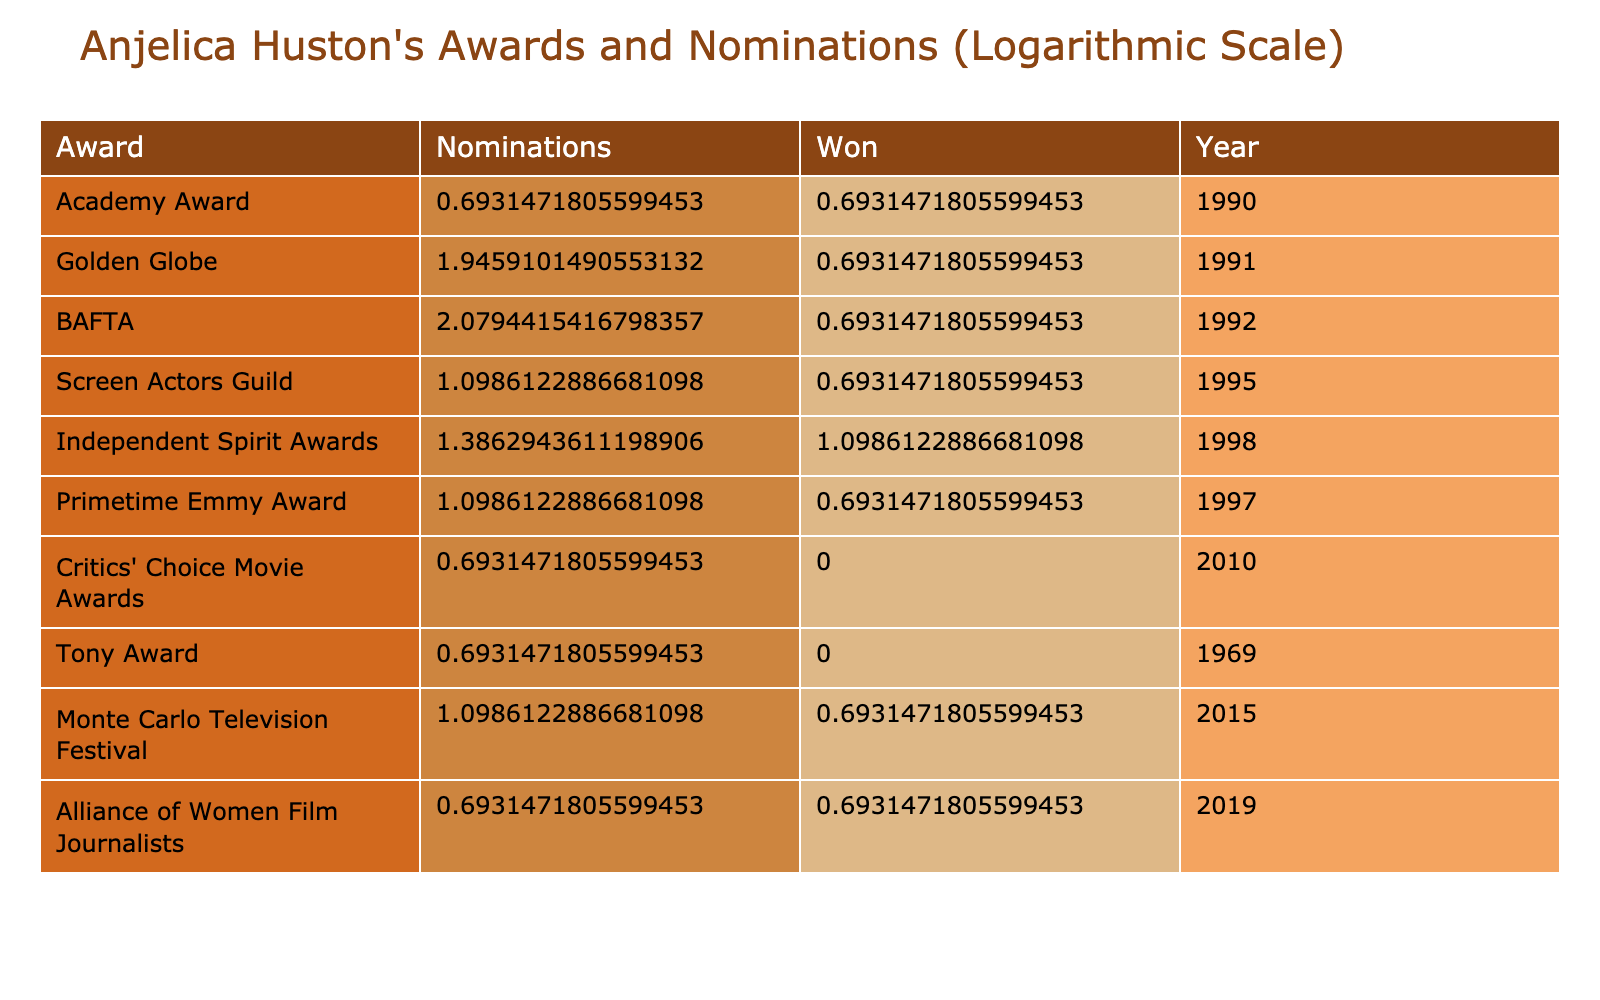What is the total number of awards Anjelica Huston has won? The table shows that Anjelica Huston has won awards in multiple categories. By adding the "Won" column values: 1 (Academy Award) + 1 (Golden Globe) + 1 (BAFTA) + 1 (Screen Actors Guild) + 2 (Independent Spirit Awards) + 1 (Primetime Emmy Award) + 0 (Critics' Choice Movie Awards) + 0 (Tony Award) + 1 (Monte Carlo Television Festival) + 1 (Alliance of Women Film Journalists) = 8.
Answer: 8 How many nominations did Anjelica Huston receive for the BAFTA? The table indicates that she received 7 nominations for the BAFTA award. The number is directly listed under the "Nominations" column for the BAFTA row.
Answer: 7 Did Anjelica Huston win any awards at the Critics' Choice Movie Awards? The table explicitly states that she did not win any awards at the Critics' Choice Movie Awards, as shown by a "0" in the "Won" column for that award.
Answer: No What is the difference between the number of nominations and wins for the Screen Actors Guild award? For the Screen Actors Guild award, Anjelica Huston received 2 nominations and won 1. The difference is calculated by subtracting the number of wins from the number of nominations: 2 - 1 = 1.
Answer: 1 What is the total number of nominations Anjelica Huston has received across all awards? To find this, we sum the "Nominations" column values: 1 + 6 + 7 + 2 + 3 + 2 + 1 + 1 + 2 + 1 = 26. This gives the total number of nominations across all awards.
Answer: 26 Which award did Anjelica Huston receive the most nominations for? By comparing the "Nominations" column, it is clear that the BAFTA stands out with the highest count of 7 nominations.
Answer: BAFTA How many awards did Anjelica Huston win compared to her total nominations? Anjelica Huston won a total of 8 awards and received 26 nominations. To compare: 8 wins out of 26 nominations translates to a winning percentage of (8/26)*100. This indicates her win ratio but maintaining direct answers, she won 8 out of a total of 26 nominations.
Answer: 8 out of 26 Did she ever receive a Tony Award nomination? The table indicates that she received 1 Tony Award, but does not specify any nominations; hence, it can be assumed she did not have nominations listed as the "Won" count is 0.
Answer: No 